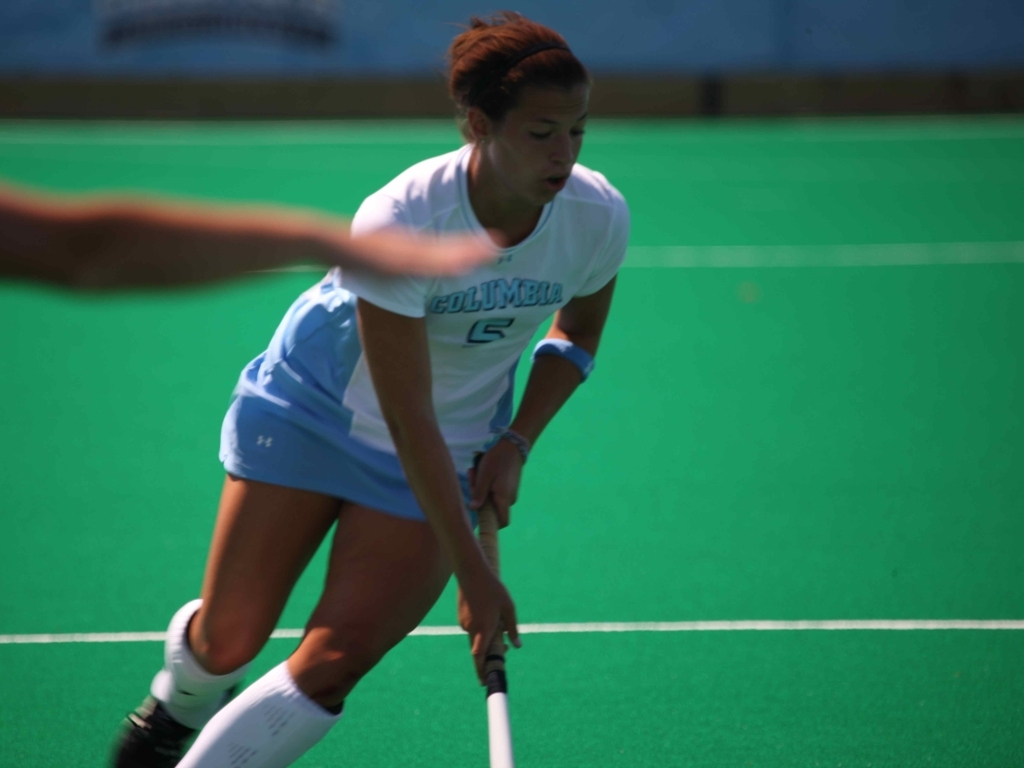What kind of sport is being played in this image? The sport being played in the image is field hockey. This can be inferred from the player's attire, the type of stick she is holding, and the visible turf. 